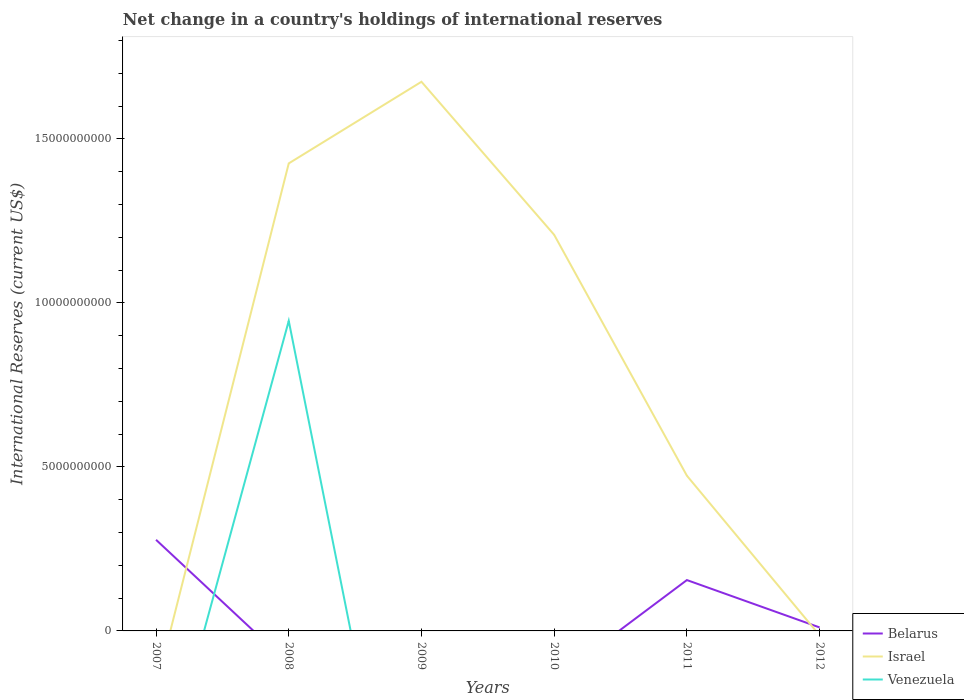Across all years, what is the maximum international reserves in Belarus?
Offer a very short reply. 0. What is the total international reserves in Israel in the graph?
Keep it short and to the point. 4.67e+09. What is the difference between the highest and the second highest international reserves in Israel?
Keep it short and to the point. 1.67e+1. Is the international reserves in Israel strictly greater than the international reserves in Belarus over the years?
Provide a short and direct response. No. How many years are there in the graph?
Provide a succinct answer. 6. What is the difference between two consecutive major ticks on the Y-axis?
Give a very brief answer. 5.00e+09. Does the graph contain grids?
Give a very brief answer. No. Where does the legend appear in the graph?
Provide a succinct answer. Bottom right. How many legend labels are there?
Offer a terse response. 3. What is the title of the graph?
Provide a short and direct response. Net change in a country's holdings of international reserves. Does "Lebanon" appear as one of the legend labels in the graph?
Ensure brevity in your answer.  No. What is the label or title of the Y-axis?
Ensure brevity in your answer.  International Reserves (current US$). What is the International Reserves (current US$) in Belarus in 2007?
Keep it short and to the point. 2.78e+09. What is the International Reserves (current US$) of Israel in 2007?
Make the answer very short. 0. What is the International Reserves (current US$) of Venezuela in 2007?
Offer a terse response. 0. What is the International Reserves (current US$) in Belarus in 2008?
Your answer should be very brief. 0. What is the International Reserves (current US$) of Israel in 2008?
Your answer should be compact. 1.43e+1. What is the International Reserves (current US$) of Venezuela in 2008?
Provide a succinct answer. 9.45e+09. What is the International Reserves (current US$) in Belarus in 2009?
Make the answer very short. 0. What is the International Reserves (current US$) in Israel in 2009?
Your response must be concise. 1.67e+1. What is the International Reserves (current US$) in Israel in 2010?
Your answer should be very brief. 1.21e+1. What is the International Reserves (current US$) in Belarus in 2011?
Keep it short and to the point. 1.55e+09. What is the International Reserves (current US$) of Israel in 2011?
Keep it short and to the point. 4.73e+09. What is the International Reserves (current US$) of Venezuela in 2011?
Offer a very short reply. 0. What is the International Reserves (current US$) in Belarus in 2012?
Your answer should be very brief. 1.07e+08. What is the International Reserves (current US$) of Israel in 2012?
Your answer should be compact. 0. Across all years, what is the maximum International Reserves (current US$) of Belarus?
Offer a terse response. 2.78e+09. Across all years, what is the maximum International Reserves (current US$) of Israel?
Your answer should be compact. 1.67e+1. Across all years, what is the maximum International Reserves (current US$) of Venezuela?
Offer a very short reply. 9.45e+09. What is the total International Reserves (current US$) in Belarus in the graph?
Ensure brevity in your answer.  4.44e+09. What is the total International Reserves (current US$) in Israel in the graph?
Ensure brevity in your answer.  4.78e+1. What is the total International Reserves (current US$) in Venezuela in the graph?
Your response must be concise. 9.45e+09. What is the difference between the International Reserves (current US$) in Belarus in 2007 and that in 2011?
Your response must be concise. 1.23e+09. What is the difference between the International Reserves (current US$) in Belarus in 2007 and that in 2012?
Offer a very short reply. 2.67e+09. What is the difference between the International Reserves (current US$) in Israel in 2008 and that in 2009?
Your answer should be very brief. -2.49e+09. What is the difference between the International Reserves (current US$) of Israel in 2008 and that in 2010?
Your response must be concise. 2.18e+09. What is the difference between the International Reserves (current US$) in Israel in 2008 and that in 2011?
Give a very brief answer. 9.52e+09. What is the difference between the International Reserves (current US$) of Israel in 2009 and that in 2010?
Provide a short and direct response. 4.67e+09. What is the difference between the International Reserves (current US$) of Israel in 2009 and that in 2011?
Keep it short and to the point. 1.20e+1. What is the difference between the International Reserves (current US$) of Israel in 2010 and that in 2011?
Offer a terse response. 7.34e+09. What is the difference between the International Reserves (current US$) in Belarus in 2011 and that in 2012?
Provide a short and direct response. 1.44e+09. What is the difference between the International Reserves (current US$) in Belarus in 2007 and the International Reserves (current US$) in Israel in 2008?
Your response must be concise. -1.15e+1. What is the difference between the International Reserves (current US$) of Belarus in 2007 and the International Reserves (current US$) of Venezuela in 2008?
Provide a succinct answer. -6.67e+09. What is the difference between the International Reserves (current US$) in Belarus in 2007 and the International Reserves (current US$) in Israel in 2009?
Your answer should be very brief. -1.40e+1. What is the difference between the International Reserves (current US$) in Belarus in 2007 and the International Reserves (current US$) in Israel in 2010?
Your response must be concise. -9.30e+09. What is the difference between the International Reserves (current US$) in Belarus in 2007 and the International Reserves (current US$) in Israel in 2011?
Your answer should be compact. -1.95e+09. What is the average International Reserves (current US$) in Belarus per year?
Keep it short and to the point. 7.39e+08. What is the average International Reserves (current US$) in Israel per year?
Provide a short and direct response. 7.97e+09. What is the average International Reserves (current US$) of Venezuela per year?
Give a very brief answer. 1.58e+09. In the year 2008, what is the difference between the International Reserves (current US$) in Israel and International Reserves (current US$) in Venezuela?
Provide a short and direct response. 4.80e+09. In the year 2011, what is the difference between the International Reserves (current US$) of Belarus and International Reserves (current US$) of Israel?
Give a very brief answer. -3.18e+09. What is the ratio of the International Reserves (current US$) of Belarus in 2007 to that in 2011?
Your response must be concise. 1.79. What is the ratio of the International Reserves (current US$) of Belarus in 2007 to that in 2012?
Keep it short and to the point. 26.07. What is the ratio of the International Reserves (current US$) of Israel in 2008 to that in 2009?
Provide a short and direct response. 0.85. What is the ratio of the International Reserves (current US$) in Israel in 2008 to that in 2010?
Offer a very short reply. 1.18. What is the ratio of the International Reserves (current US$) of Israel in 2008 to that in 2011?
Your answer should be compact. 3.01. What is the ratio of the International Reserves (current US$) of Israel in 2009 to that in 2010?
Offer a very short reply. 1.39. What is the ratio of the International Reserves (current US$) of Israel in 2009 to that in 2011?
Provide a short and direct response. 3.54. What is the ratio of the International Reserves (current US$) of Israel in 2010 to that in 2011?
Your answer should be compact. 2.55. What is the ratio of the International Reserves (current US$) in Belarus in 2011 to that in 2012?
Your response must be concise. 14.55. What is the difference between the highest and the second highest International Reserves (current US$) in Belarus?
Make the answer very short. 1.23e+09. What is the difference between the highest and the second highest International Reserves (current US$) in Israel?
Provide a succinct answer. 2.49e+09. What is the difference between the highest and the lowest International Reserves (current US$) in Belarus?
Your answer should be compact. 2.78e+09. What is the difference between the highest and the lowest International Reserves (current US$) of Israel?
Your response must be concise. 1.67e+1. What is the difference between the highest and the lowest International Reserves (current US$) of Venezuela?
Give a very brief answer. 9.45e+09. 